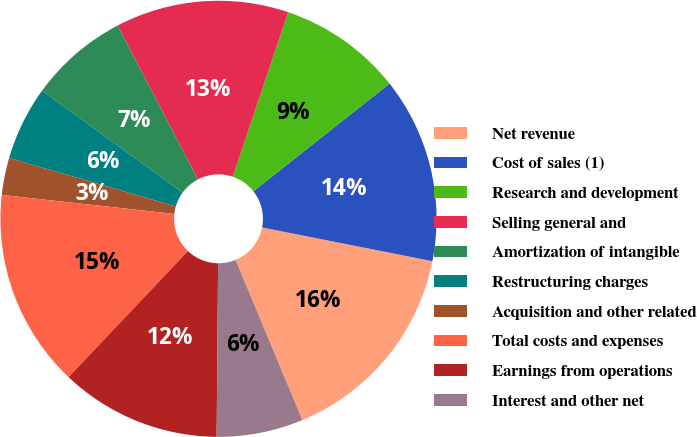<chart> <loc_0><loc_0><loc_500><loc_500><pie_chart><fcel>Net revenue<fcel>Cost of sales (1)<fcel>Research and development<fcel>Selling general and<fcel>Amortization of intangible<fcel>Restructuring charges<fcel>Acquisition and other related<fcel>Total costs and expenses<fcel>Earnings from operations<fcel>Interest and other net<nl><fcel>15.6%<fcel>13.76%<fcel>9.17%<fcel>12.84%<fcel>7.34%<fcel>5.5%<fcel>2.75%<fcel>14.68%<fcel>11.93%<fcel>6.42%<nl></chart> 